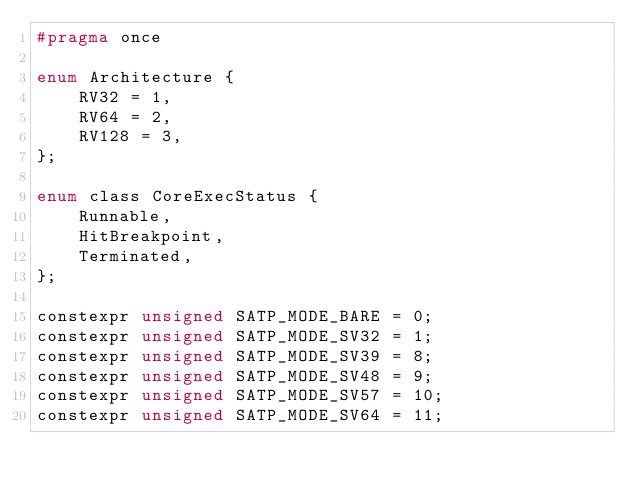<code> <loc_0><loc_0><loc_500><loc_500><_C_>#pragma once

enum Architecture {
	RV32 = 1,
	RV64 = 2,
	RV128 = 3,
};

enum class CoreExecStatus {
	Runnable,
	HitBreakpoint,
	Terminated,
};

constexpr unsigned SATP_MODE_BARE = 0;
constexpr unsigned SATP_MODE_SV32 = 1;
constexpr unsigned SATP_MODE_SV39 = 8;
constexpr unsigned SATP_MODE_SV48 = 9;
constexpr unsigned SATP_MODE_SV57 = 10;
constexpr unsigned SATP_MODE_SV64 = 11;</code> 